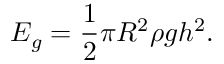<formula> <loc_0><loc_0><loc_500><loc_500>E _ { g } = \frac { 1 } { 2 } \pi R ^ { 2 } \rho g h ^ { 2 } .</formula> 